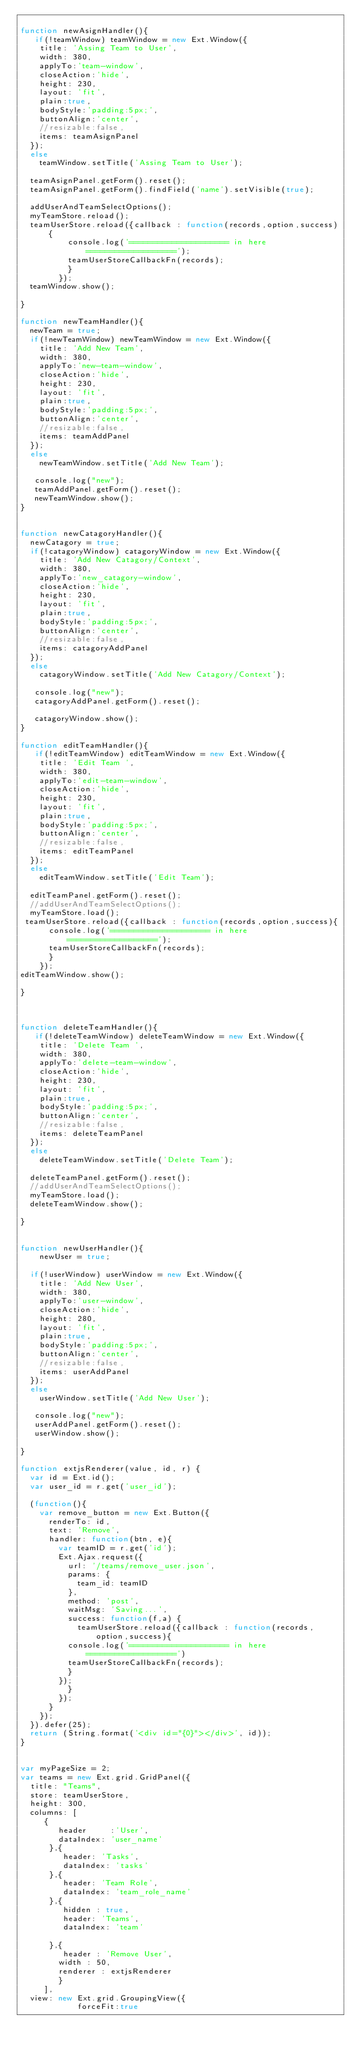Convert code to text. <code><loc_0><loc_0><loc_500><loc_500><_JavaScript_>
function newAsignHandler(){
   if(!teamWindow) teamWindow = new Ext.Window({
    title: 'Assing Team to User',
    width: 380,
    applyTo:'team-window',
    closeAction:'hide',
    height: 230,
    layout: 'fit',
    plain:true,
    bodyStyle:'padding:5px;',
    buttonAlign:'center',
    //resizable:false,
    items: teamAsignPanel
  });
  else
    teamWindow.setTitle('Assing Team to User');
   
  teamAsignPanel.getForm().reset();
  teamAsignPanel.getForm().findField('name').setVisible(true); 
 
  addUserAndTeamSelectOptions();
  myTeamStore.reload();
  teamUserStore.reload({callback : function(records,option,success){
          console.log('===================== in here ===================');
          teamUserStoreCallbackFn(records);
          }
        });
  teamWindow.show();

}

function newTeamHandler(){
  newTeam = true;
  if(!newTeamWindow) newTeamWindow = new Ext.Window({
    title: 'Add New Team',
    width: 380,
    applyTo:'new-team-window',
    closeAction:'hide',
    height: 230,
    layout: 'fit',
    plain:true,
    bodyStyle:'padding:5px;',
    buttonAlign:'center',
    //resizable:false,
    items: teamAddPanel
  });
  else
    newTeamWindow.setTitle('Add New Team');
   
   console.log("new");
   teamAddPanel.getForm().reset();
   newTeamWindow.show();
}


function newCatagoryHandler(){    
  newCatagory = true;
  if(!catagoryWindow) catagoryWindow = new Ext.Window({
    title: 'Add New Catagory/Context',
    width: 380,
    applyTo:'new_catagory-window',
    closeAction:'hide',
    height: 230,
    layout: 'fit',
    plain:true,
    bodyStyle:'padding:5px;',
    buttonAlign:'center',
    //resizable:false,
    items: catagoryAddPanel
  });
  else
    catagoryWindow.setTitle('Add New Catagory/Context');
   
   console.log("new");
   catagoryAddPanel.getForm().reset();
   
   catagoryWindow.show();
}

function editTeamHandler(){
   if(!editTeamWindow) editTeamWindow = new Ext.Window({
    title: 'Edit Team ',
    width: 380,
    applyTo:'edit-team-window',
    closeAction:'hide',
    height: 230,
    layout: 'fit',
    plain:true,
    bodyStyle:'padding:5px;',
    buttonAlign:'center',
    //resizable:false,
    items: editTeamPanel
  });
  else
    editTeamWindow.setTitle('Edit Team');
   
  editTeamPanel.getForm().reset();
  //addUserAndTeamSelectOptions();
  myTeamStore.load();
 teamUserStore.reload({callback : function(records,option,success){
      console.log('===================== in here ===================');
      teamUserStoreCallbackFn(records);
      }
    });
editTeamWindow.show();

}



function deleteTeamHandler(){
   if(!deleteTeamWindow) deleteTeamWindow = new Ext.Window({
    title: 'Delete Team ',
    width: 380,
    applyTo:'delete-team-window',
    closeAction:'hide',
    height: 230,
    layout: 'fit',
    plain:true,
    bodyStyle:'padding:5px;',
    buttonAlign:'center',
    //resizable:false,
    items: deleteTeamPanel
  });
  else
    deleteTeamWindow.setTitle('Delete Team');
   
  deleteTeamPanel.getForm().reset();
  //addUserAndTeamSelectOptions();
  myTeamStore.load();
  deleteTeamWindow.show();
 
}


function newUserHandler(){
    newUser = true;

  if(!userWindow) userWindow = new Ext.Window({
    title: 'Add New User',
    width: 380,
    applyTo:'user-window',
    closeAction:'hide',
    height: 280,
    layout: 'fit',
    plain:true,
    bodyStyle:'padding:5px;',
    buttonAlign:'center',
    //resizable:false,
    items: userAddPanel
  });
  else
    userWindow.setTitle('Add New User');
   
   console.log("new");
   userAddPanel.getForm().reset();
   userWindow.show();

}

function extjsRenderer(value, id, r) {
	var id = Ext.id();
	var user_id = r.get('user_id');

	(function(){
    var remove_button = new Ext.Button({
      renderTo: id,
      text: 'Remove',
      handler: function(btn, e){
        var teamID = r.get('id');
        Ext.Ajax.request({
          url: '/teams/remove_user.json',
          params: {
            team_id: teamID
          },
          method: 'post',
          waitMsg: 'Saving...',
          success: function(f,a) {
            teamUserStore.reload({callback : function(records,option,success){
          console.log('===================== in here ===================')
          teamUserStoreCallbackFn(records);
          }
        });
          }
        });
      }
    });
	}).defer(25);
	return (String.format('<div id="{0}"></div>', id));
}


var myPageSize = 2;
var teams = new Ext.grid.GridPanel({
  title: "Teams",
  store: teamUserStore,
  height: 300,
  columns: [
     {
        header     :'User',
        dataIndex: 'user_name'
      },{
         header: 'Tasks',
         dataIndex: 'tasks'
      },{
         header: 'Team Role',
         dataIndex: 'team_role_name'
      },{
         hidden : true,
         header: 'Teams',
         dataIndex: 'team'

      },{
         header : 'Remove User',
 		    width : 50,
 		    renderer : extjsRenderer
        }
     ],
  view: new Ext.grid.GroupingView({
            forceFit:true</code> 